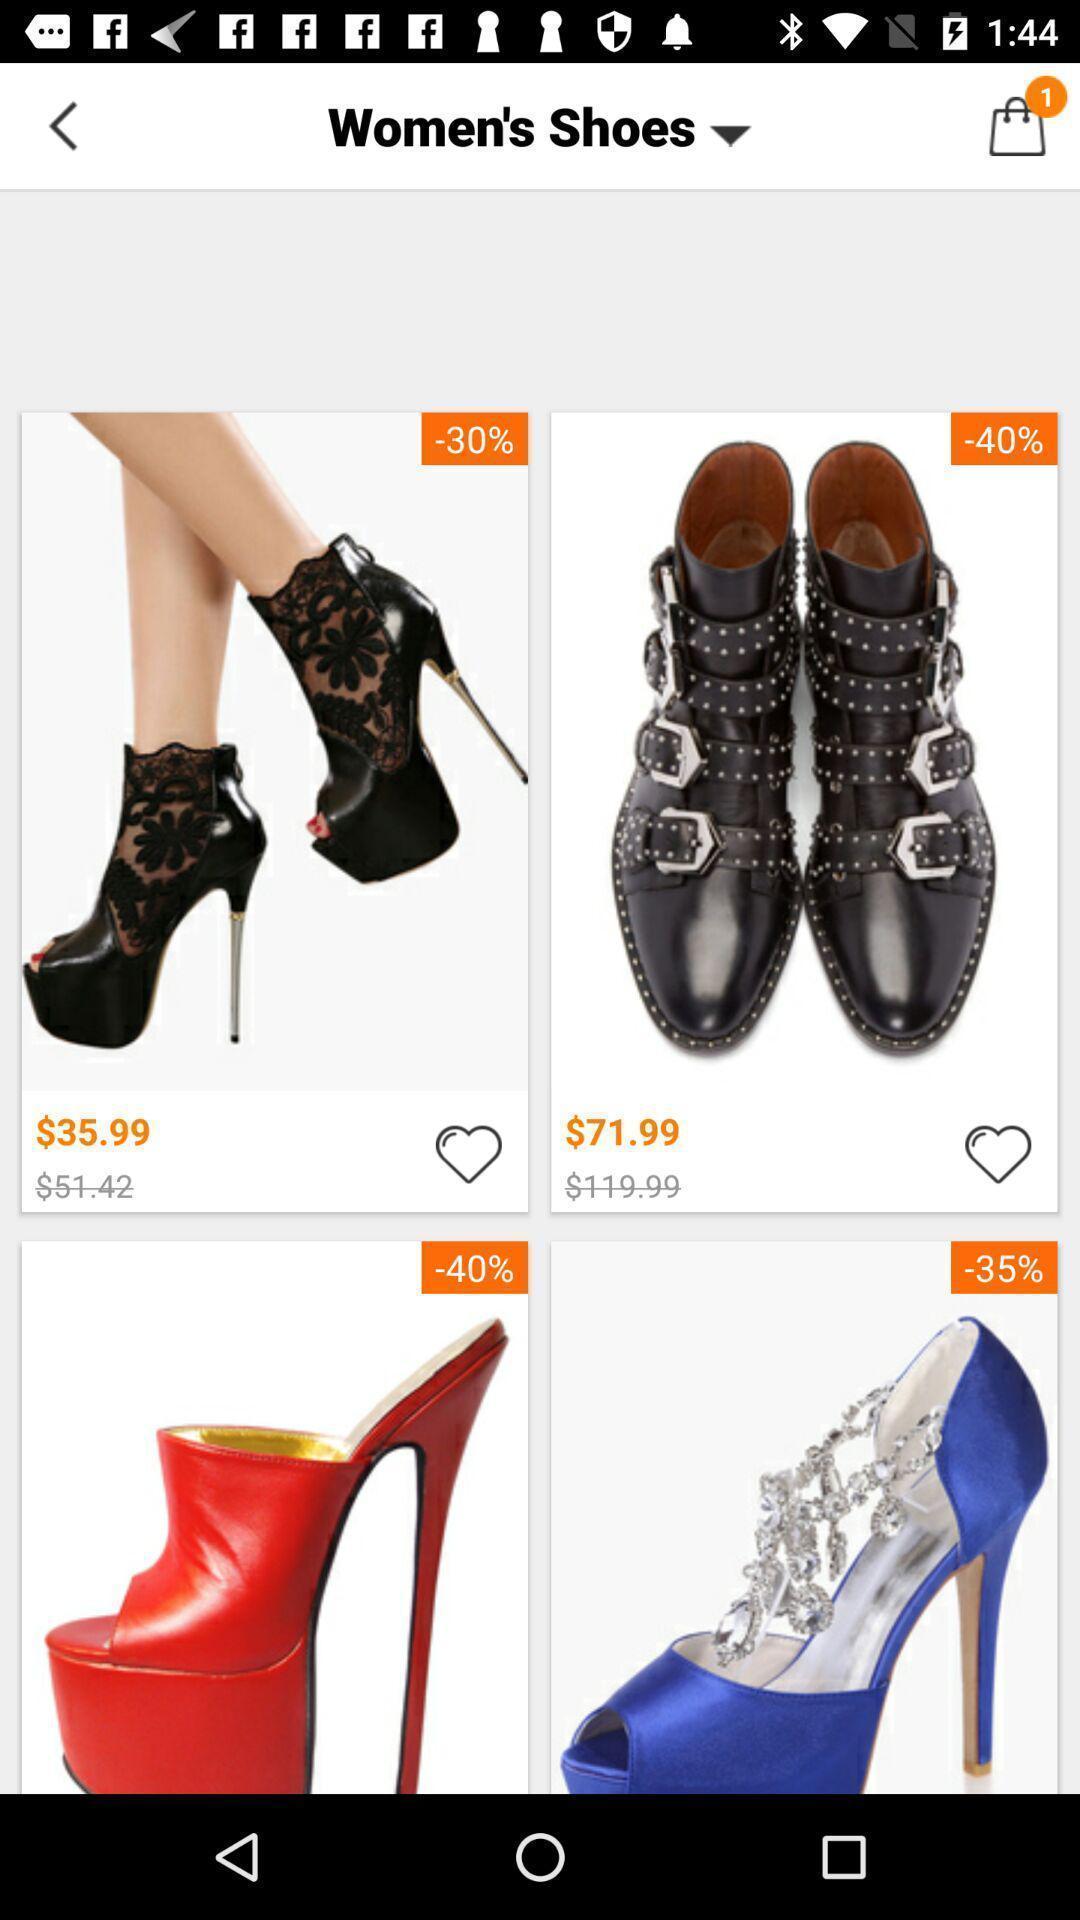Provide a textual representation of this image. Page displaying various products in shopping app. 